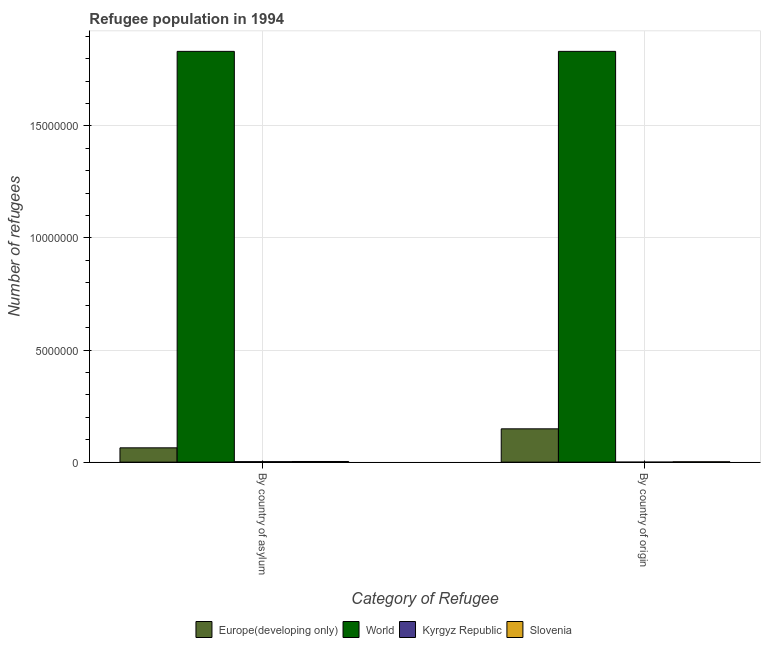How many groups of bars are there?
Your answer should be compact. 2. Are the number of bars on each tick of the X-axis equal?
Give a very brief answer. Yes. How many bars are there on the 1st tick from the right?
Ensure brevity in your answer.  4. What is the label of the 1st group of bars from the left?
Offer a very short reply. By country of asylum. What is the number of refugees by country of origin in Europe(developing only)?
Your answer should be compact. 1.49e+06. Across all countries, what is the maximum number of refugees by country of asylum?
Ensure brevity in your answer.  1.83e+07. Across all countries, what is the minimum number of refugees by country of origin?
Offer a very short reply. 14. In which country was the number of refugees by country of asylum minimum?
Give a very brief answer. Kyrgyz Republic. What is the total number of refugees by country of origin in the graph?
Your answer should be very brief. 1.98e+07. What is the difference between the number of refugees by country of asylum in World and that in Europe(developing only)?
Your response must be concise. 1.77e+07. What is the difference between the number of refugees by country of asylum in Kyrgyz Republic and the number of refugees by country of origin in World?
Your answer should be very brief. -1.83e+07. What is the average number of refugees by country of origin per country?
Your answer should be very brief. 4.96e+06. What is the difference between the number of refugees by country of asylum and number of refugees by country of origin in Europe(developing only)?
Ensure brevity in your answer.  -8.48e+05. In how many countries, is the number of refugees by country of asylum greater than 4000000 ?
Offer a very short reply. 1. What is the ratio of the number of refugees by country of origin in World to that in Slovenia?
Make the answer very short. 1235.79. In how many countries, is the number of refugees by country of origin greater than the average number of refugees by country of origin taken over all countries?
Give a very brief answer. 1. What does the 3rd bar from the left in By country of asylum represents?
Offer a terse response. Kyrgyz Republic. What does the 4th bar from the right in By country of origin represents?
Provide a succinct answer. Europe(developing only). How many bars are there?
Give a very brief answer. 8. Are all the bars in the graph horizontal?
Make the answer very short. No. How many countries are there in the graph?
Provide a succinct answer. 4. Does the graph contain any zero values?
Offer a very short reply. No. Does the graph contain grids?
Give a very brief answer. Yes. Where does the legend appear in the graph?
Make the answer very short. Bottom center. How many legend labels are there?
Provide a succinct answer. 4. What is the title of the graph?
Your answer should be very brief. Refugee population in 1994. Does "North America" appear as one of the legend labels in the graph?
Your response must be concise. No. What is the label or title of the X-axis?
Give a very brief answer. Category of Refugee. What is the label or title of the Y-axis?
Your answer should be compact. Number of refugees. What is the Number of refugees in Europe(developing only) in By country of asylum?
Your answer should be very brief. 6.38e+05. What is the Number of refugees of World in By country of asylum?
Provide a short and direct response. 1.83e+07. What is the Number of refugees of Kyrgyz Republic in By country of asylum?
Provide a succinct answer. 2.12e+04. What is the Number of refugees in Slovenia in By country of asylum?
Ensure brevity in your answer.  2.92e+04. What is the Number of refugees of Europe(developing only) in By country of origin?
Provide a succinct answer. 1.49e+06. What is the Number of refugees of World in By country of origin?
Provide a succinct answer. 1.83e+07. What is the Number of refugees in Slovenia in By country of origin?
Make the answer very short. 1.48e+04. Across all Category of Refugee, what is the maximum Number of refugees of Europe(developing only)?
Keep it short and to the point. 1.49e+06. Across all Category of Refugee, what is the maximum Number of refugees in World?
Make the answer very short. 1.83e+07. Across all Category of Refugee, what is the maximum Number of refugees in Kyrgyz Republic?
Your answer should be compact. 2.12e+04. Across all Category of Refugee, what is the maximum Number of refugees in Slovenia?
Give a very brief answer. 2.92e+04. Across all Category of Refugee, what is the minimum Number of refugees of Europe(developing only)?
Your answer should be very brief. 6.38e+05. Across all Category of Refugee, what is the minimum Number of refugees of World?
Give a very brief answer. 1.83e+07. Across all Category of Refugee, what is the minimum Number of refugees of Kyrgyz Republic?
Offer a terse response. 14. Across all Category of Refugee, what is the minimum Number of refugees of Slovenia?
Ensure brevity in your answer.  1.48e+04. What is the total Number of refugees in Europe(developing only) in the graph?
Your answer should be very brief. 2.12e+06. What is the total Number of refugees of World in the graph?
Your answer should be very brief. 3.67e+07. What is the total Number of refugees of Kyrgyz Republic in the graph?
Ensure brevity in your answer.  2.13e+04. What is the total Number of refugees of Slovenia in the graph?
Provide a succinct answer. 4.40e+04. What is the difference between the Number of refugees of Europe(developing only) in By country of asylum and that in By country of origin?
Provide a short and direct response. -8.48e+05. What is the difference between the Number of refugees of Kyrgyz Republic in By country of asylum and that in By country of origin?
Provide a short and direct response. 2.12e+04. What is the difference between the Number of refugees of Slovenia in By country of asylum and that in By country of origin?
Give a very brief answer. 1.43e+04. What is the difference between the Number of refugees in Europe(developing only) in By country of asylum and the Number of refugees in World in By country of origin?
Your answer should be very brief. -1.77e+07. What is the difference between the Number of refugees of Europe(developing only) in By country of asylum and the Number of refugees of Kyrgyz Republic in By country of origin?
Ensure brevity in your answer.  6.38e+05. What is the difference between the Number of refugees in Europe(developing only) in By country of asylum and the Number of refugees in Slovenia in By country of origin?
Keep it short and to the point. 6.23e+05. What is the difference between the Number of refugees of World in By country of asylum and the Number of refugees of Kyrgyz Republic in By country of origin?
Your answer should be compact. 1.83e+07. What is the difference between the Number of refugees in World in By country of asylum and the Number of refugees in Slovenia in By country of origin?
Offer a very short reply. 1.83e+07. What is the difference between the Number of refugees of Kyrgyz Republic in By country of asylum and the Number of refugees of Slovenia in By country of origin?
Ensure brevity in your answer.  6410. What is the average Number of refugees of Europe(developing only) per Category of Refugee?
Give a very brief answer. 1.06e+06. What is the average Number of refugees of World per Category of Refugee?
Offer a terse response. 1.83e+07. What is the average Number of refugees in Kyrgyz Republic per Category of Refugee?
Ensure brevity in your answer.  1.06e+04. What is the average Number of refugees of Slovenia per Category of Refugee?
Offer a terse response. 2.20e+04. What is the difference between the Number of refugees of Europe(developing only) and Number of refugees of World in By country of asylum?
Make the answer very short. -1.77e+07. What is the difference between the Number of refugees of Europe(developing only) and Number of refugees of Kyrgyz Republic in By country of asylum?
Make the answer very short. 6.17e+05. What is the difference between the Number of refugees of Europe(developing only) and Number of refugees of Slovenia in By country of asylum?
Offer a very short reply. 6.09e+05. What is the difference between the Number of refugees of World and Number of refugees of Kyrgyz Republic in By country of asylum?
Offer a terse response. 1.83e+07. What is the difference between the Number of refugees of World and Number of refugees of Slovenia in By country of asylum?
Keep it short and to the point. 1.83e+07. What is the difference between the Number of refugees of Kyrgyz Republic and Number of refugees of Slovenia in By country of asylum?
Offer a very short reply. -7917. What is the difference between the Number of refugees in Europe(developing only) and Number of refugees in World in By country of origin?
Offer a very short reply. -1.68e+07. What is the difference between the Number of refugees of Europe(developing only) and Number of refugees of Kyrgyz Republic in By country of origin?
Ensure brevity in your answer.  1.49e+06. What is the difference between the Number of refugees of Europe(developing only) and Number of refugees of Slovenia in By country of origin?
Provide a short and direct response. 1.47e+06. What is the difference between the Number of refugees of World and Number of refugees of Kyrgyz Republic in By country of origin?
Provide a short and direct response. 1.83e+07. What is the difference between the Number of refugees in World and Number of refugees in Slovenia in By country of origin?
Your response must be concise. 1.83e+07. What is the difference between the Number of refugees in Kyrgyz Republic and Number of refugees in Slovenia in By country of origin?
Offer a very short reply. -1.48e+04. What is the ratio of the Number of refugees in Europe(developing only) in By country of asylum to that in By country of origin?
Provide a short and direct response. 0.43. What is the ratio of the Number of refugees in World in By country of asylum to that in By country of origin?
Provide a succinct answer. 1. What is the ratio of the Number of refugees of Kyrgyz Republic in By country of asylum to that in By country of origin?
Your response must be concise. 1517.07. What is the ratio of the Number of refugees of Slovenia in By country of asylum to that in By country of origin?
Provide a succinct answer. 1.97. What is the difference between the highest and the second highest Number of refugees in Europe(developing only)?
Keep it short and to the point. 8.48e+05. What is the difference between the highest and the second highest Number of refugees in World?
Make the answer very short. 0. What is the difference between the highest and the second highest Number of refugees of Kyrgyz Republic?
Provide a short and direct response. 2.12e+04. What is the difference between the highest and the second highest Number of refugees in Slovenia?
Offer a very short reply. 1.43e+04. What is the difference between the highest and the lowest Number of refugees in Europe(developing only)?
Make the answer very short. 8.48e+05. What is the difference between the highest and the lowest Number of refugees in World?
Your response must be concise. 0. What is the difference between the highest and the lowest Number of refugees in Kyrgyz Republic?
Give a very brief answer. 2.12e+04. What is the difference between the highest and the lowest Number of refugees in Slovenia?
Your response must be concise. 1.43e+04. 